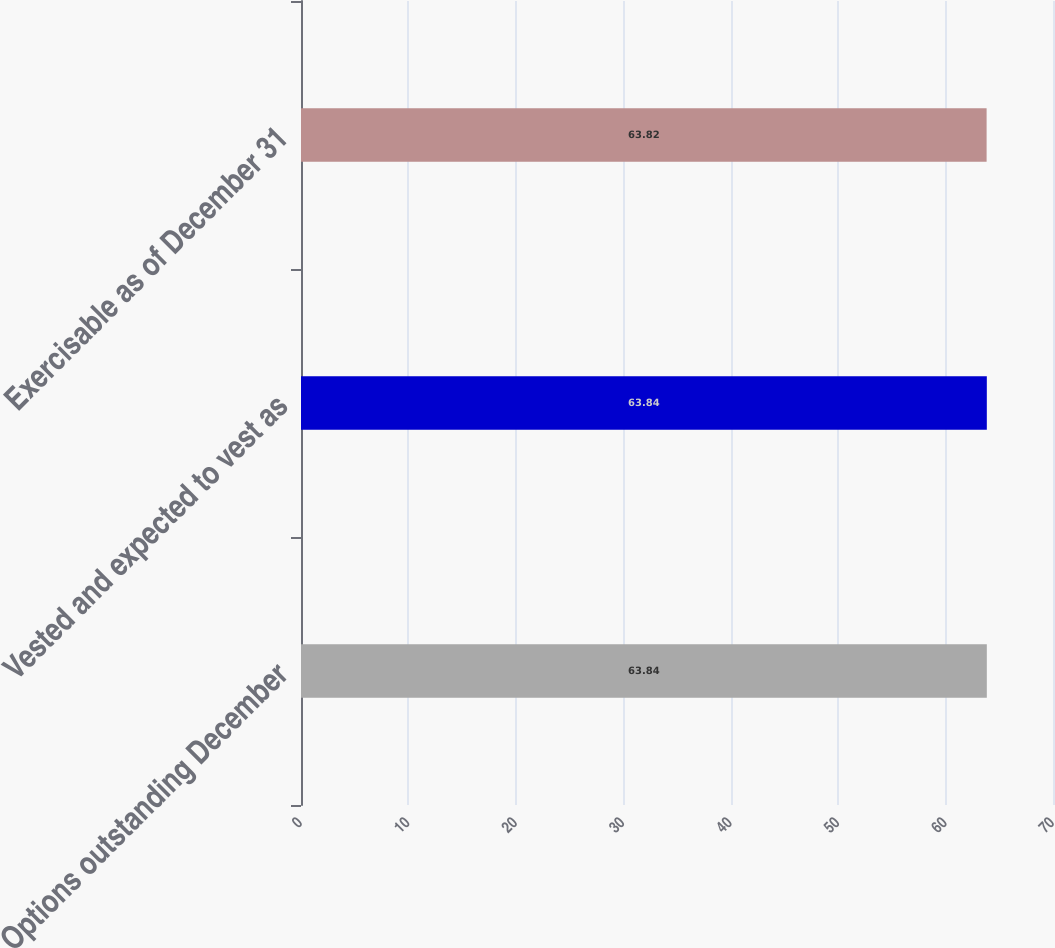Convert chart. <chart><loc_0><loc_0><loc_500><loc_500><bar_chart><fcel>Options outstanding December<fcel>Vested and expected to vest as<fcel>Exercisable as of December 31<nl><fcel>63.84<fcel>63.84<fcel>63.82<nl></chart> 